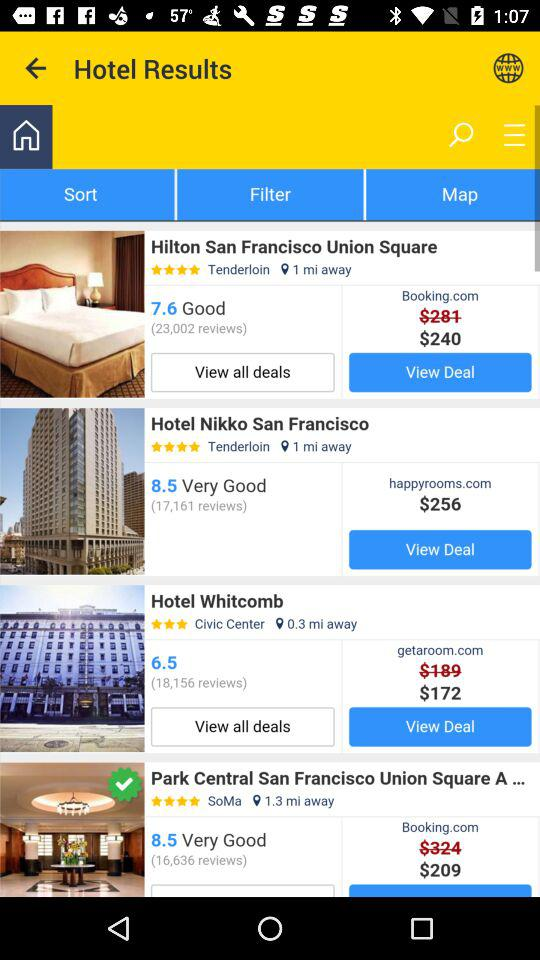What is the after discount price of Park Central San Francisco Union Square? The after discount price is $209. 